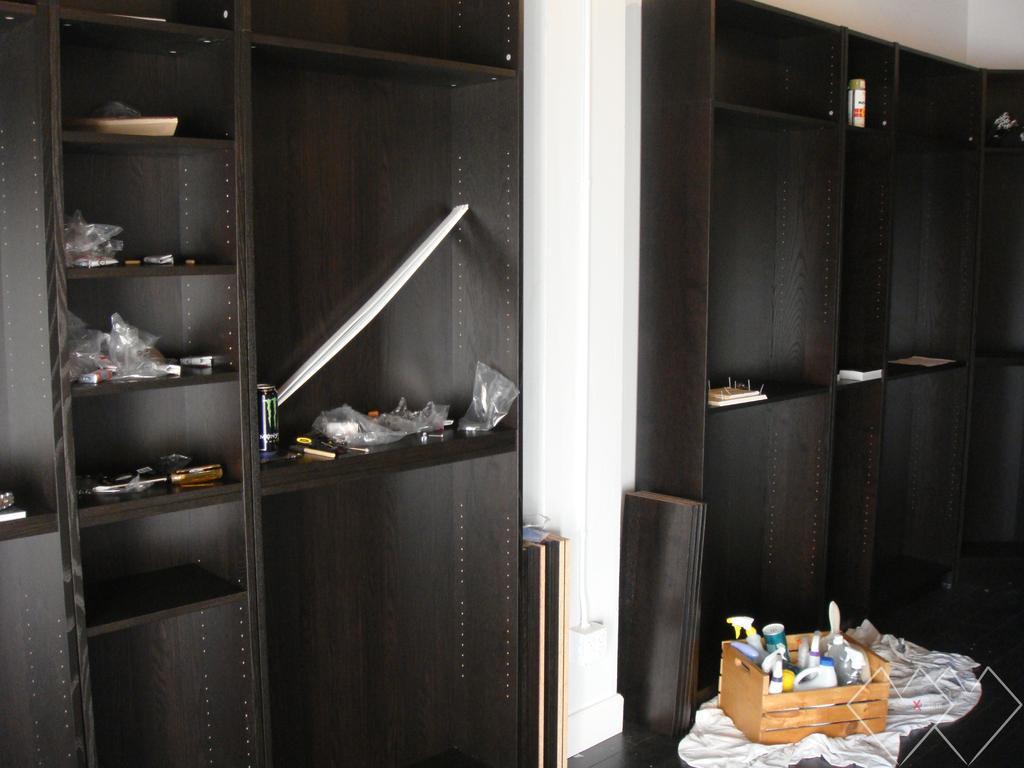Describe this image in one or two sentences. In this image I can see cupboards. It is in black color and some objects are in it. In front I can see bottles in the wooden box and we can see white cloth. The wall is in white color. 